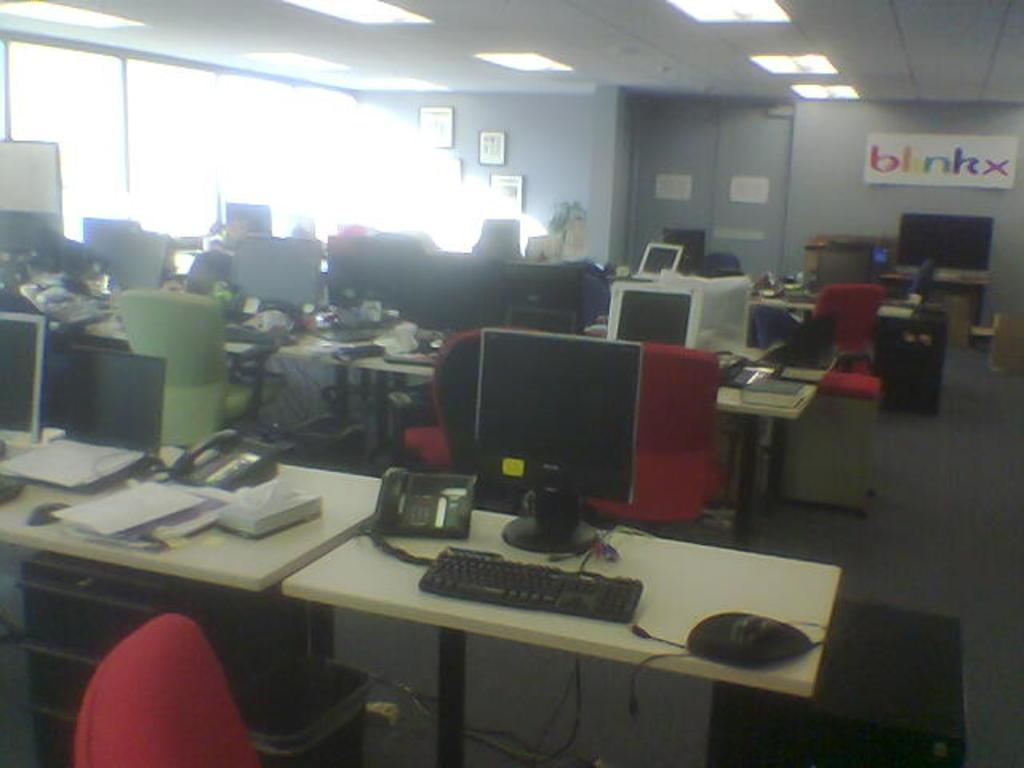<image>
Share a concise interpretation of the image provided. a sign with the word blinkx on it in an office 